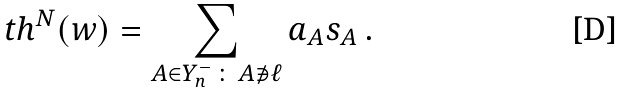<formula> <loc_0><loc_0><loc_500><loc_500>\ t h ^ { N } ( w ) = \sum _ { A \in Y ^ { - } _ { n } \, \colon \, A \not \ni \ell } a _ { A } s _ { A } \, .</formula> 